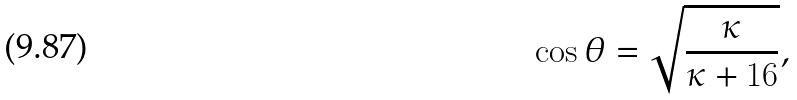Convert formula to latex. <formula><loc_0><loc_0><loc_500><loc_500>\cos \theta = \sqrt { \frac { \kappa } { \kappa + 1 6 } } ,</formula> 